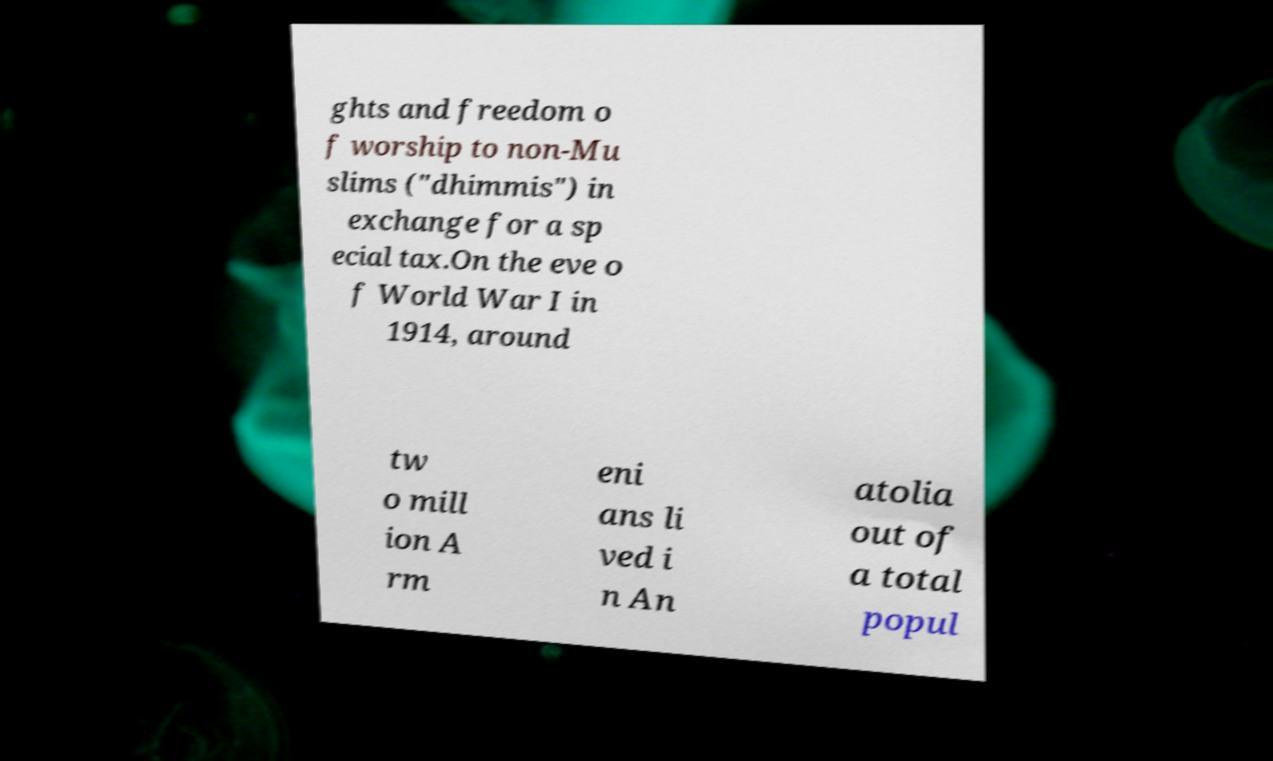For documentation purposes, I need the text within this image transcribed. Could you provide that? ghts and freedom o f worship to non-Mu slims ("dhimmis") in exchange for a sp ecial tax.On the eve o f World War I in 1914, around tw o mill ion A rm eni ans li ved i n An atolia out of a total popul 